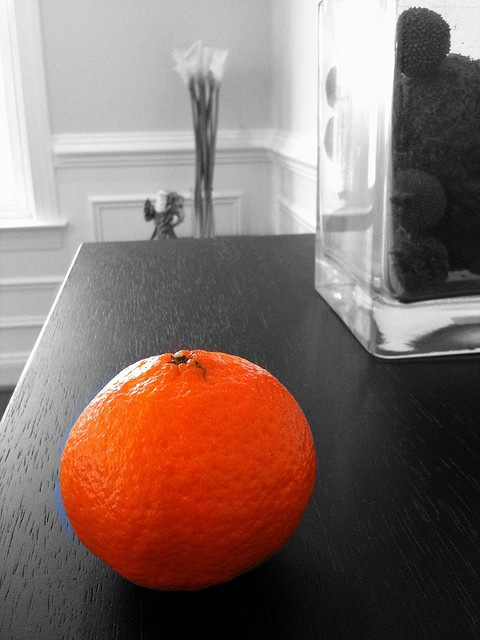Describe the objects in this image and their specific colors. I can see dining table in white, black, gray, red, and darkgray tones, orange in white, red, brown, and maroon tones, vase in white, gray, darkgray, lightgray, and black tones, and vase in white, gray, black, darkgray, and lightgray tones in this image. 